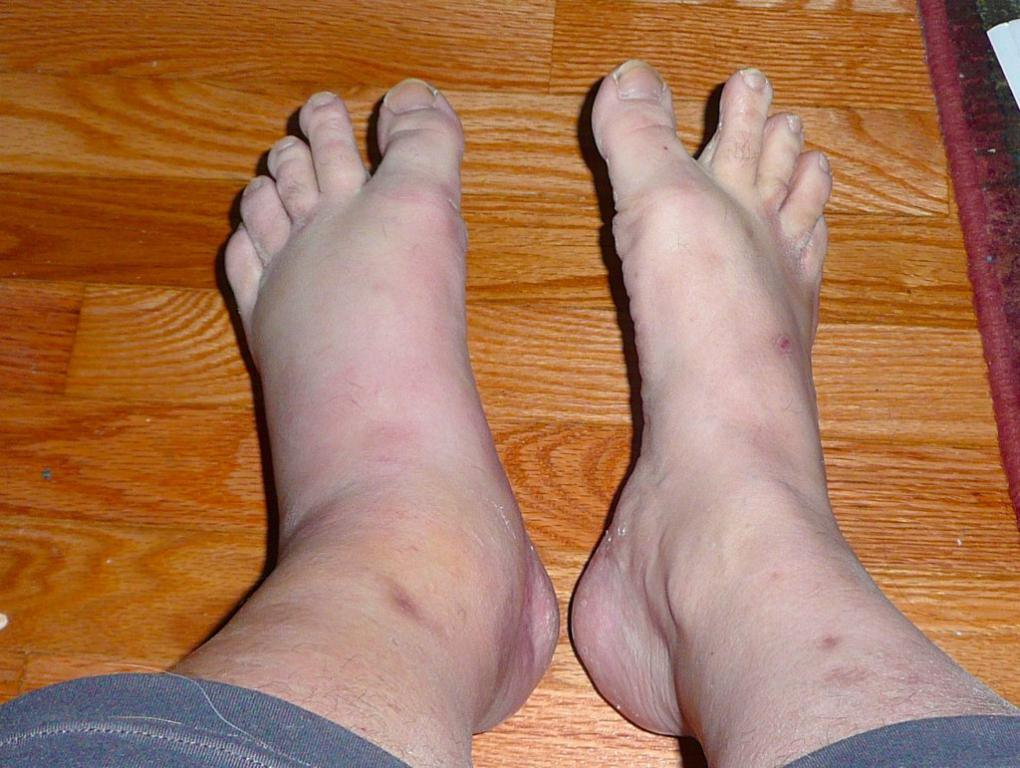What is the focus of the image? The image is zoomed in, focusing on the legs of a person. What is the position of the person's legs in the image? The legs of the person are placed on the ground. What type of advertisement can be seen in the background of the image? There is no background or advertisement present in the image; it only shows the legs of a person. 